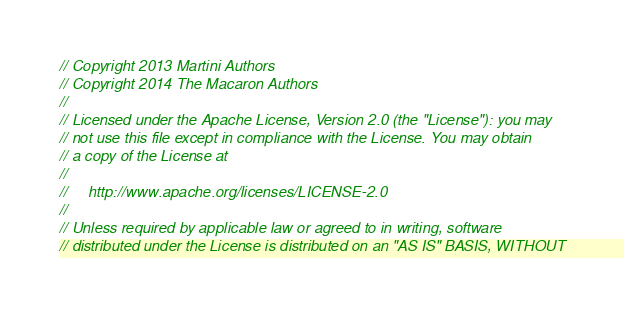<code> <loc_0><loc_0><loc_500><loc_500><_Go_>// Copyright 2013 Martini Authors
// Copyright 2014 The Macaron Authors
//
// Licensed under the Apache License, Version 2.0 (the "License"): you may
// not use this file except in compliance with the License. You may obtain
// a copy of the License at
//
//     http://www.apache.org/licenses/LICENSE-2.0
//
// Unless required by applicable law or agreed to in writing, software
// distributed under the License is distributed on an "AS IS" BASIS, WITHOUT</code> 